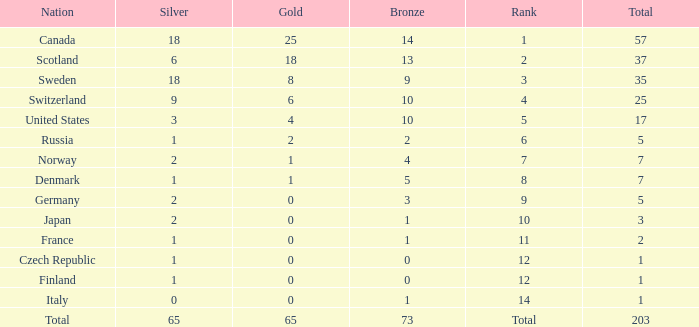What is the number of bronze medals when the total is greater than 1, more than 2 silver medals are won, and the rank is 2? 13.0. 